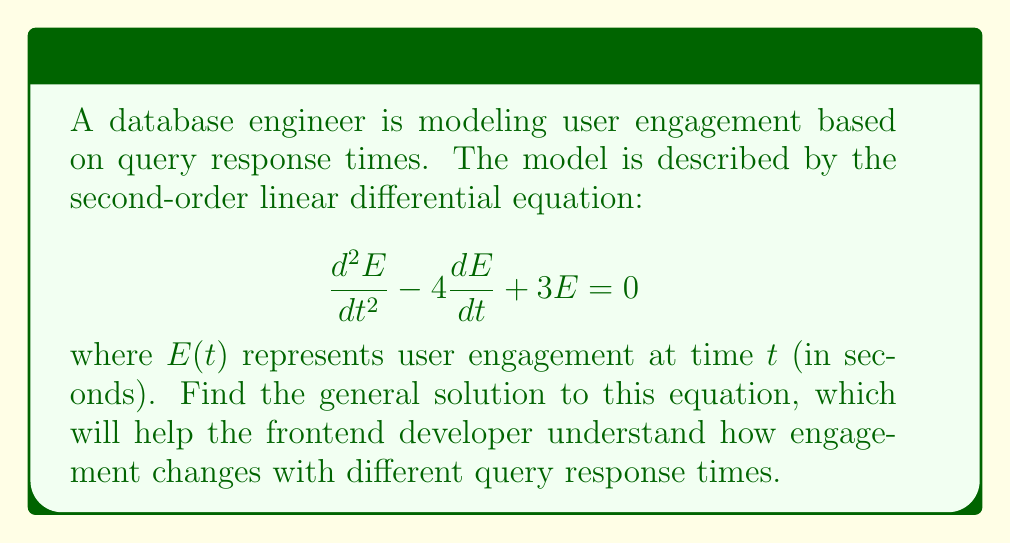Help me with this question. Let's solve this step-by-step:

1) The characteristic equation for this differential equation is:
   $$r^2 - 4r + 3 = 0$$

2) We can solve this quadratic equation using the quadratic formula:
   $$r = \frac{-b \pm \sqrt{b^2 - 4ac}}{2a}$$
   where $a=1$, $b=-4$, and $c=3$

3) Substituting these values:
   $$r = \frac{4 \pm \sqrt{16 - 12}}{2} = \frac{4 \pm \sqrt{4}}{2} = \frac{4 \pm 2}{2}$$

4) This gives us two roots:
   $$r_1 = \frac{4 + 2}{2} = 3$$ and $$r_2 = \frac{4 - 2}{2} = 1$$

5) The general solution to a second-order linear differential equation with distinct real roots is:
   $$E(t) = c_1e^{r_1t} + c_2e^{r_2t}$$

6) Substituting our roots:
   $$E(t) = c_1e^{3t} + c_2e^t$$

This solution shows that user engagement is a combination of two exponential functions, one growing faster ($e^{3t}$) and one growing slower ($e^t$). The constants $c_1$ and $c_2$ would be determined by initial conditions.
Answer: $E(t) = c_1e^{3t} + c_2e^t$ 